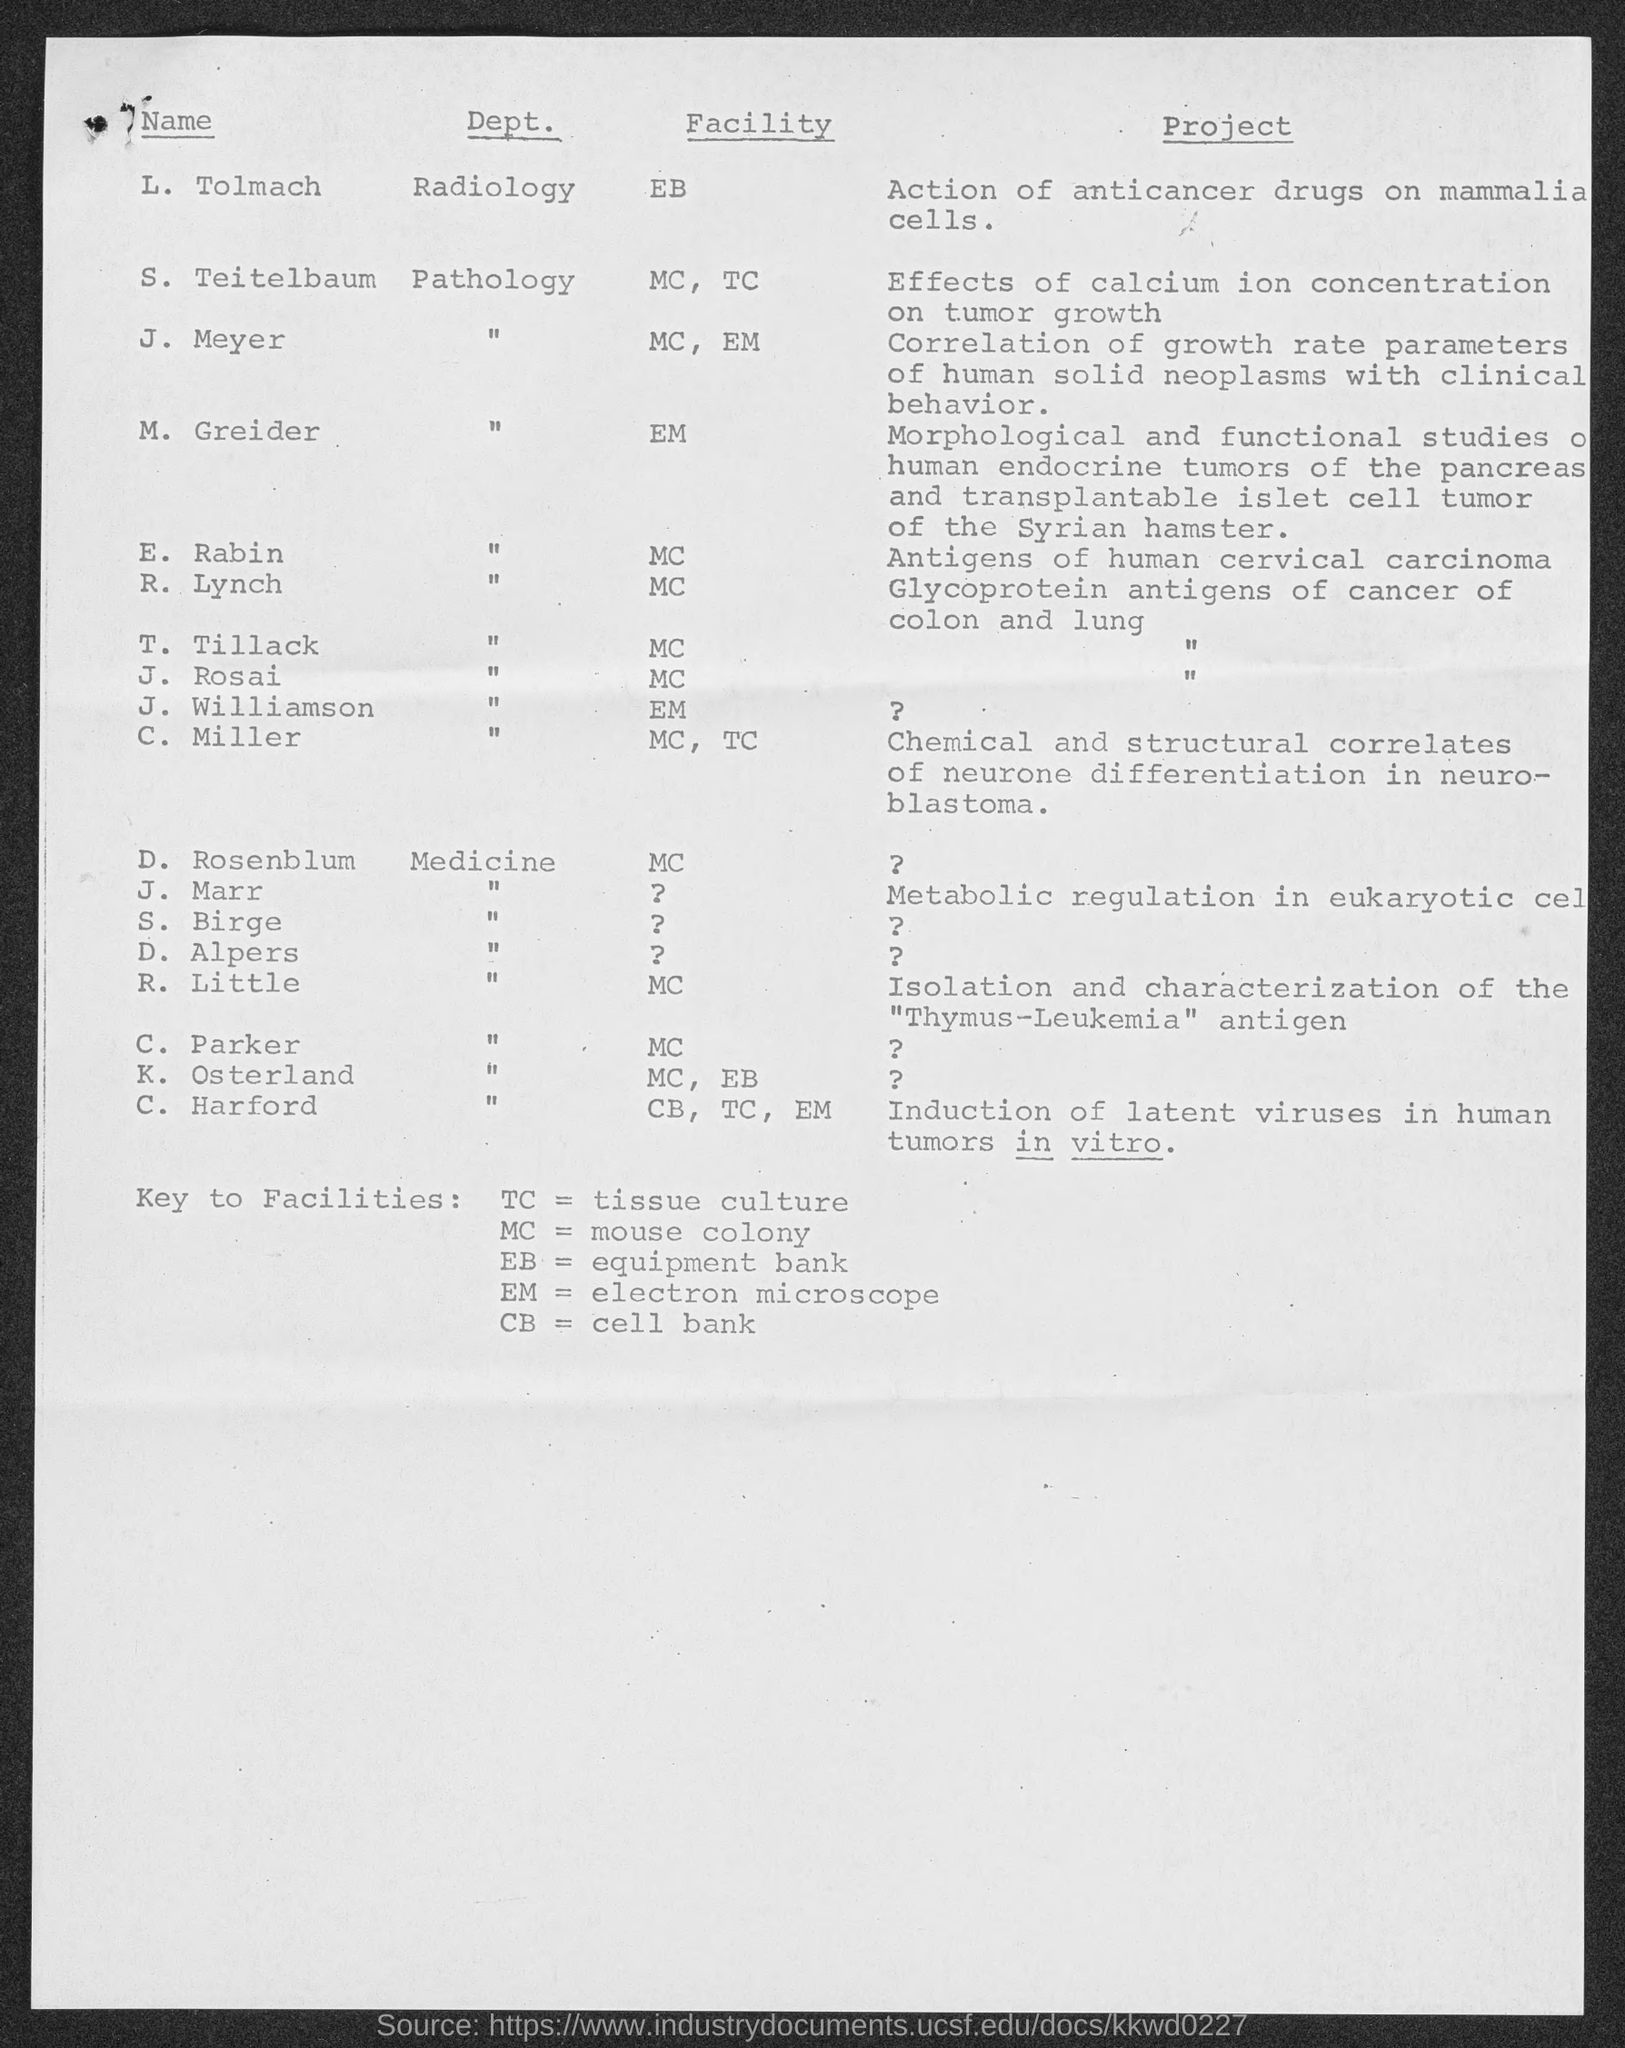Identify some key points in this picture. J. Meyer is affiliated with the facilities of MC and EM. The facility referred to as R. Lynch is located at MC... M. Greider is in a facility. R. Little is located at the facility that is designated as MC. The facility referred to as L. Tolmach is EB.. 